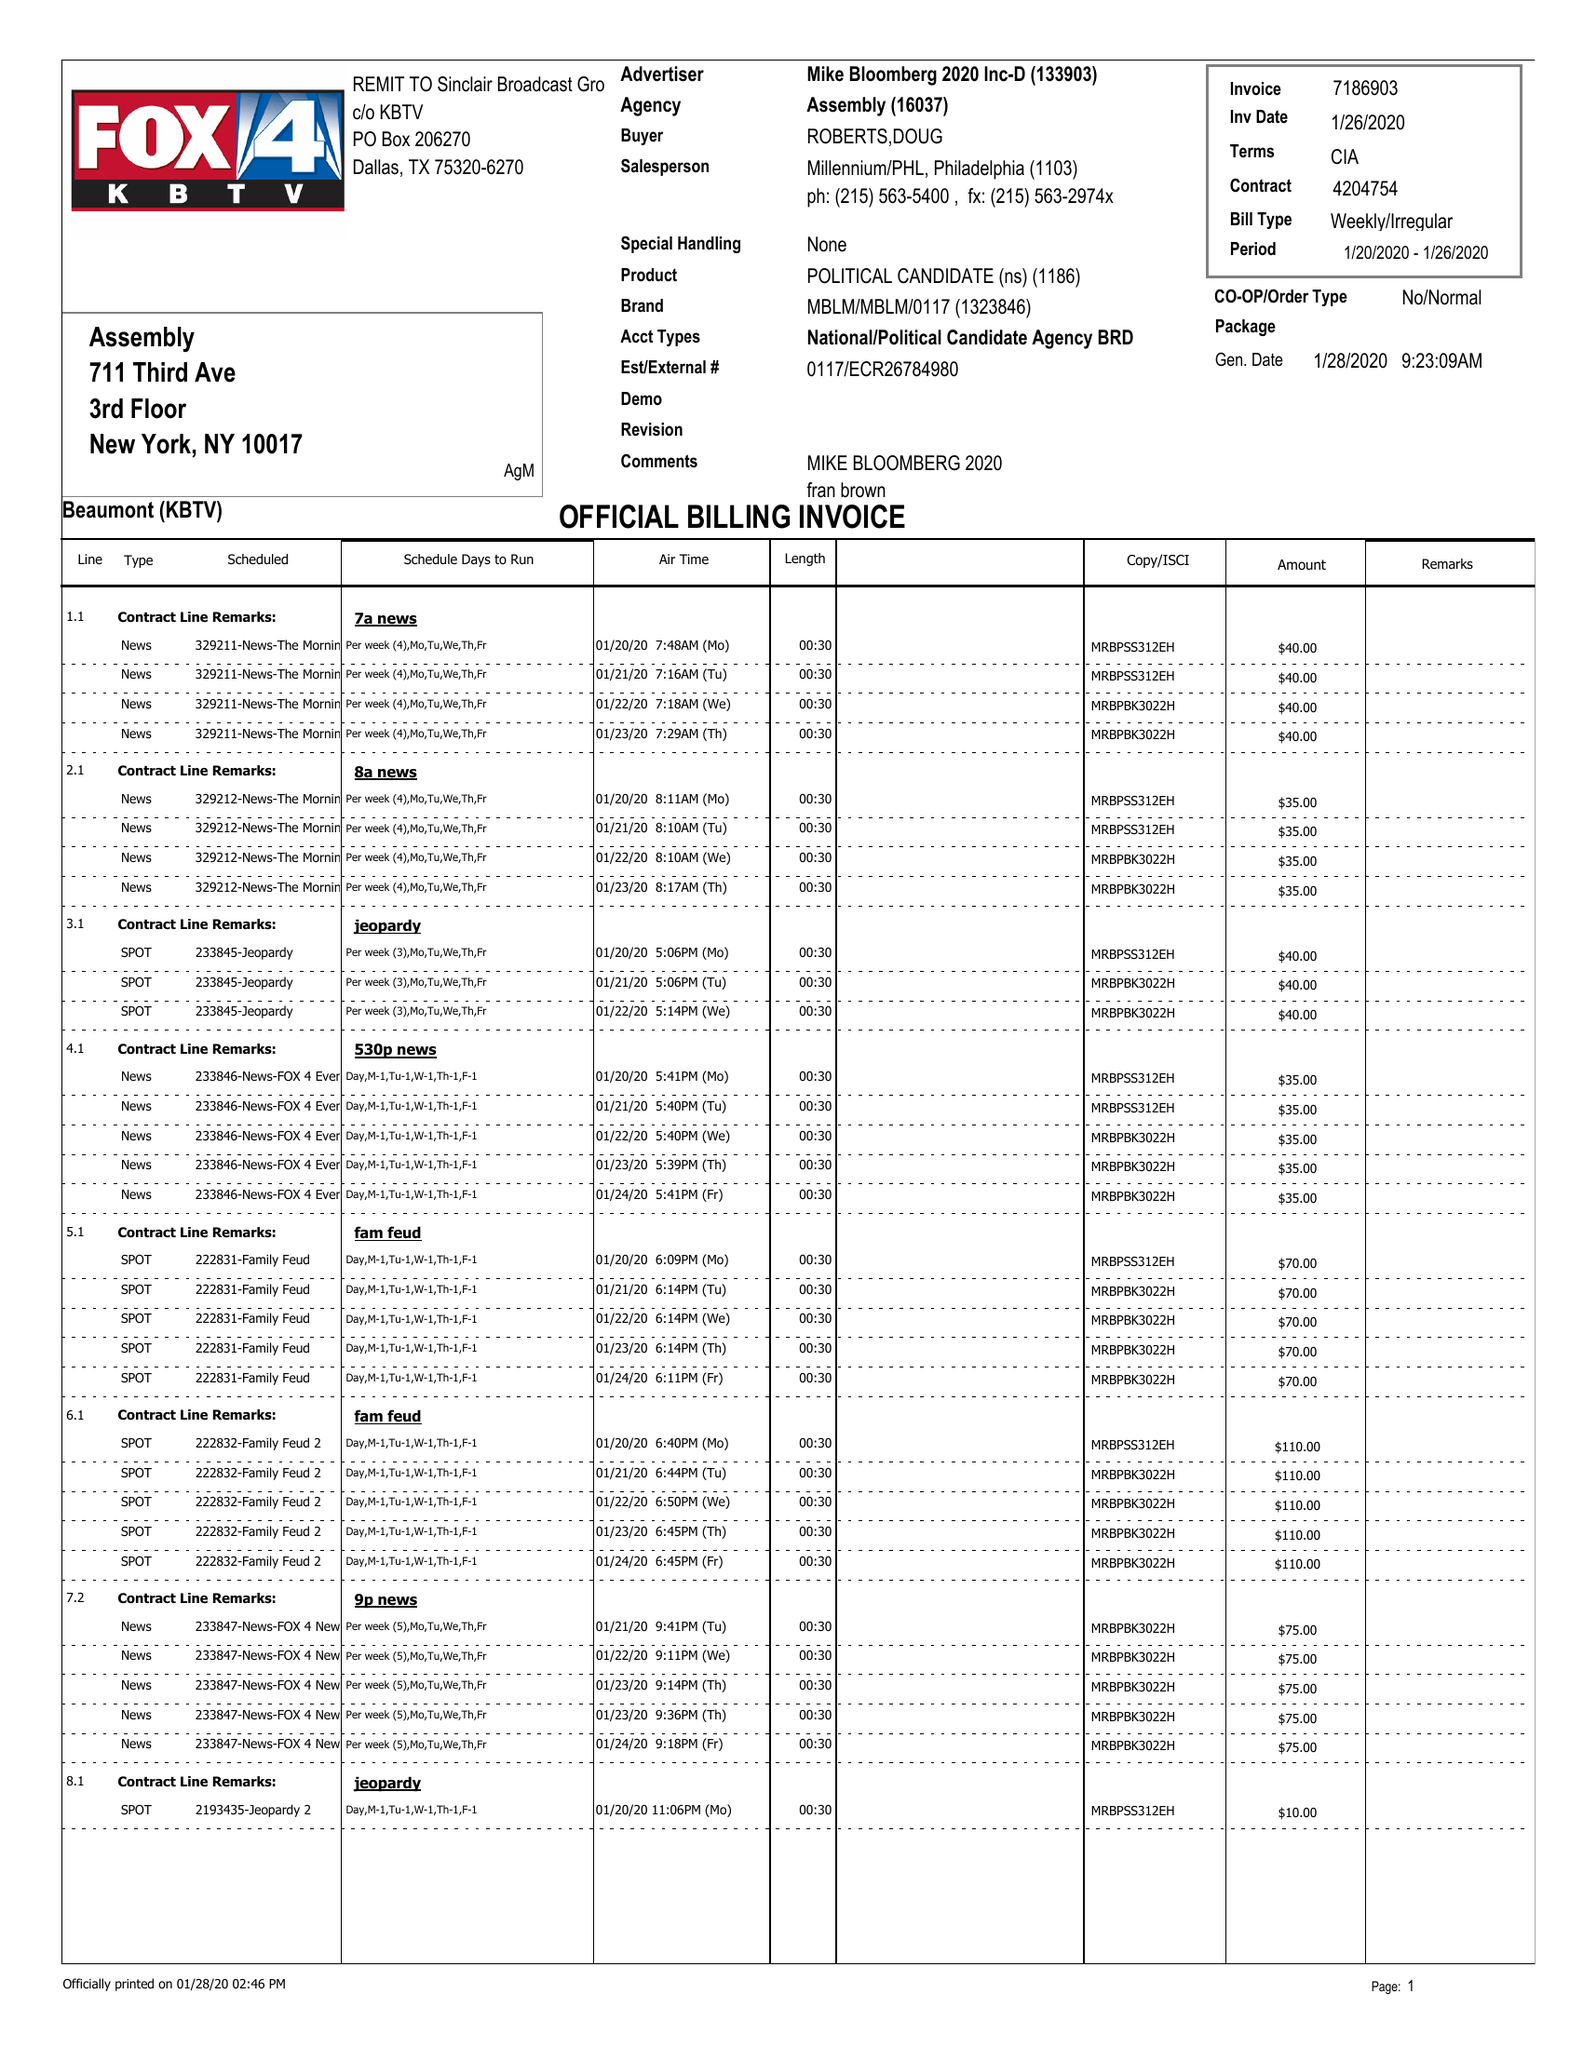What is the value for the advertiser?
Answer the question using a single word or phrase. MIKE BLOOMBERG 2020 INC-D 